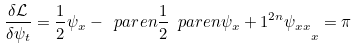<formula> <loc_0><loc_0><loc_500><loc_500>\frac { \delta \mathcal { L } } { \delta \psi _ { t } } = \frac { 1 } { 2 } \psi _ { x } - \ p a r e n { \frac { 1 } { 2 } \ p a r e n { \psi _ { x } + 1 } ^ { 2 n } \psi _ { x x } } _ { x } = \pi</formula> 